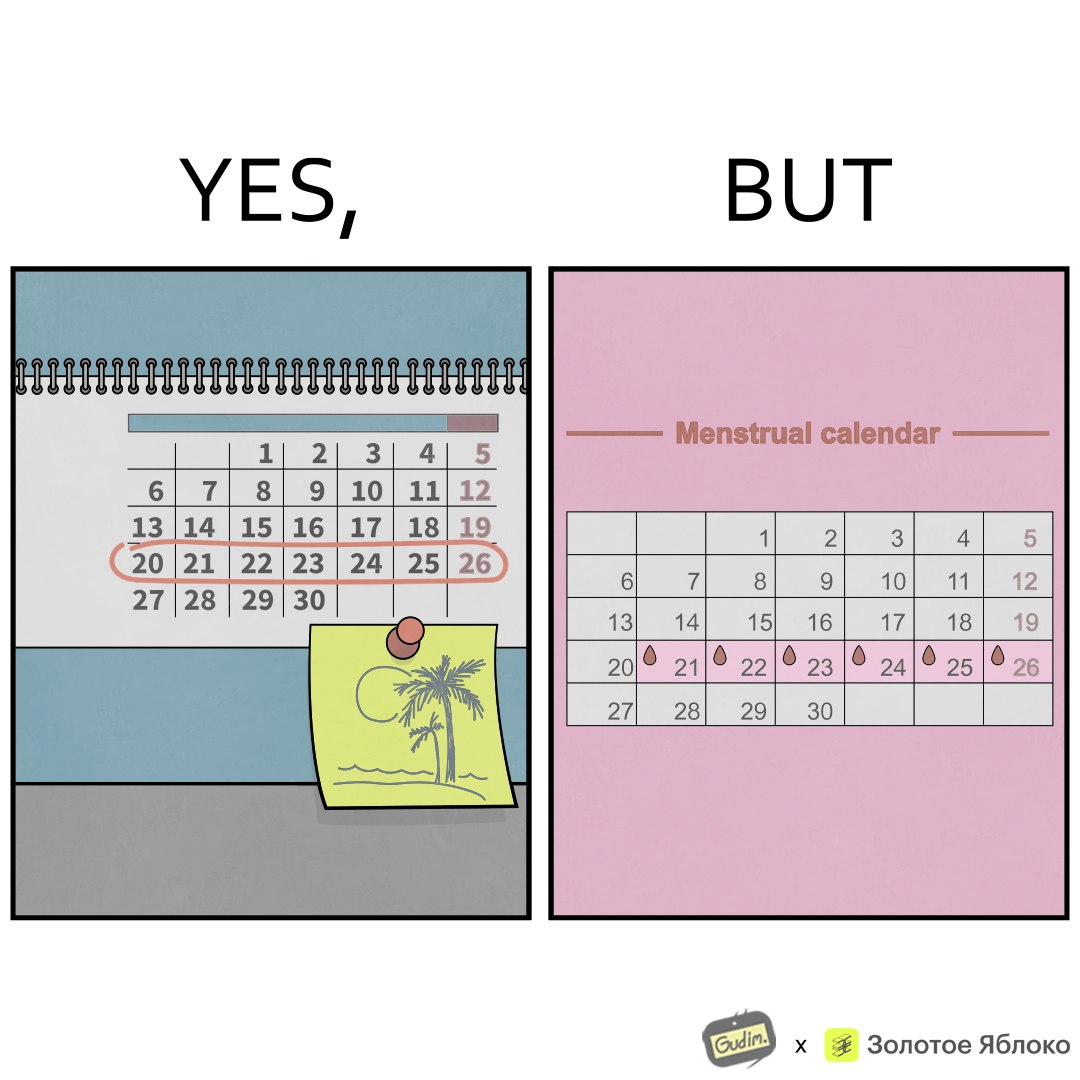What is shown in this image? The images are funny since they show how women plan out holidays with much care but their menstrual cycles ruin their plans by causing trouble due to bleeding and discomfort that occur during menstruation 